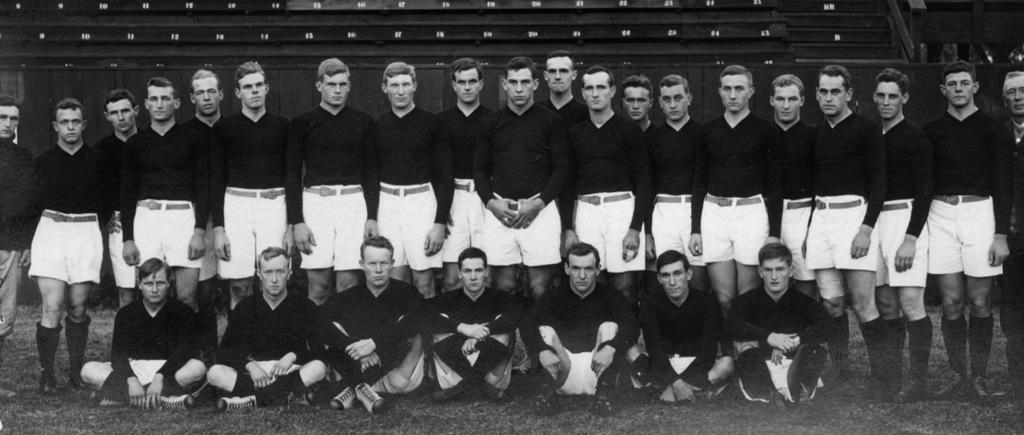What is the composition of the group in the image? There is a group of men in the image, with some sitting and some standing. What can be seen in the background of the image? There is a wall, steps, and some objects in the background of the image. What type of alley can be seen in the image? There is no alley present in the image. What are the men talking about in the image? The image does not provide any information about the conversation or topic of discussion among the men. 